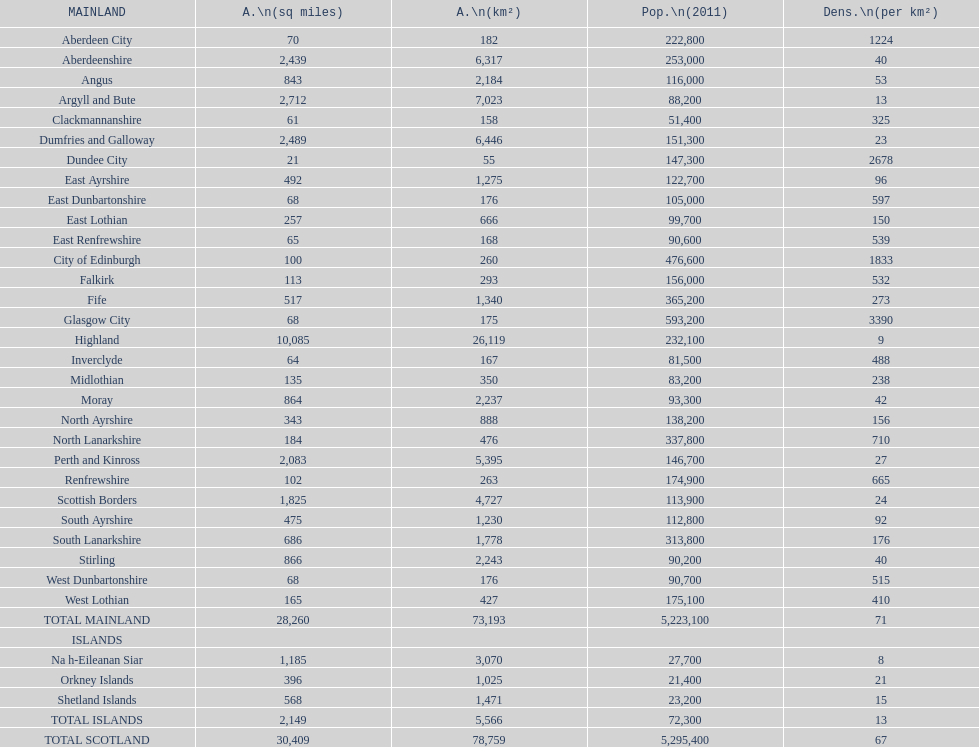If you were to arrange the locations from the smallest to largest area, which one would be first on the list? Dundee City. 